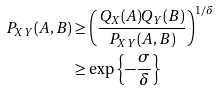Convert formula to latex. <formula><loc_0><loc_0><loc_500><loc_500>P _ { X Y } ( A , B ) & \geq \left ( \frac { Q _ { X } ( A ) Q _ { Y } ( B ) } { P _ { X Y } ( A , B ) } \right ) ^ { 1 / \delta } \\ & \geq \exp \left \{ - \frac { \sigma } { \delta } \right \}</formula> 